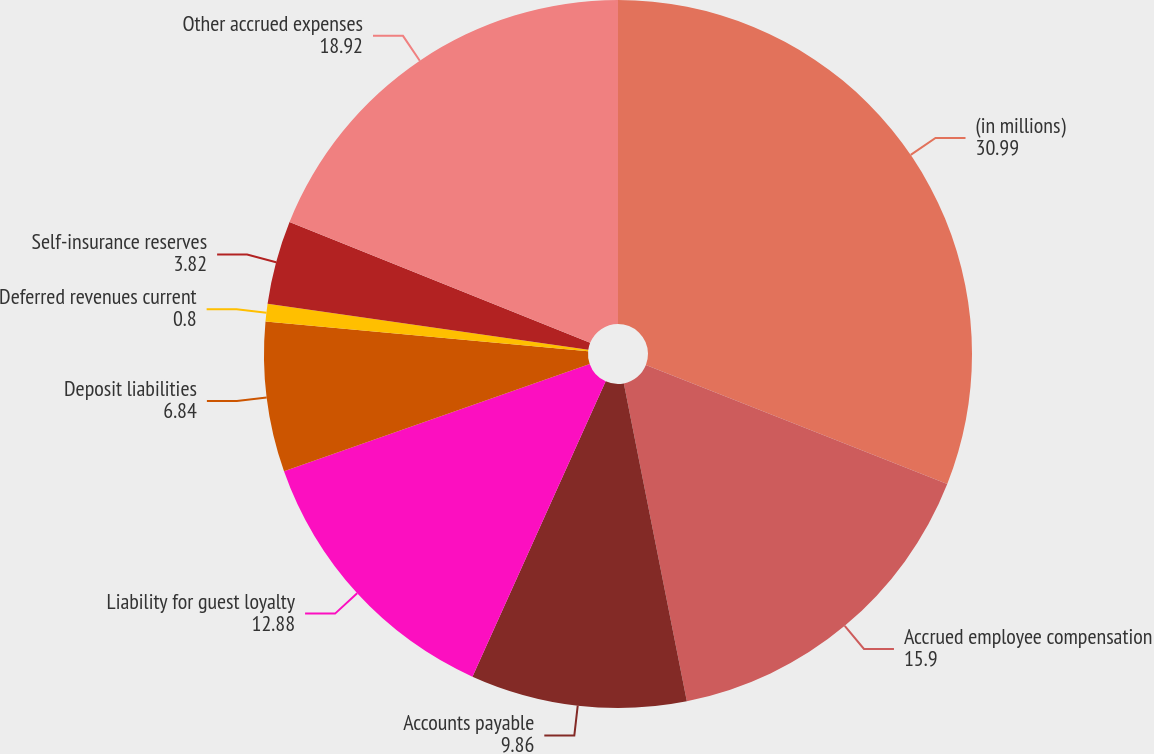Convert chart to OTSL. <chart><loc_0><loc_0><loc_500><loc_500><pie_chart><fcel>(in millions)<fcel>Accrued employee compensation<fcel>Accounts payable<fcel>Liability for guest loyalty<fcel>Deposit liabilities<fcel>Deferred revenues current<fcel>Self-insurance reserves<fcel>Other accrued expenses<nl><fcel>30.99%<fcel>15.9%<fcel>9.86%<fcel>12.88%<fcel>6.84%<fcel>0.8%<fcel>3.82%<fcel>18.92%<nl></chart> 